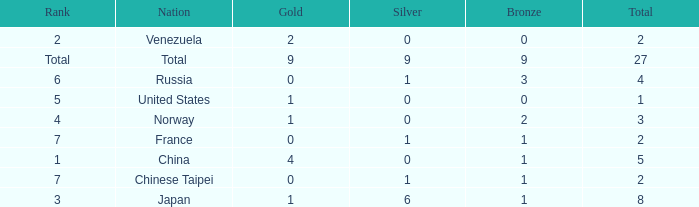What is the sum of Total when rank is 2? 2.0. 